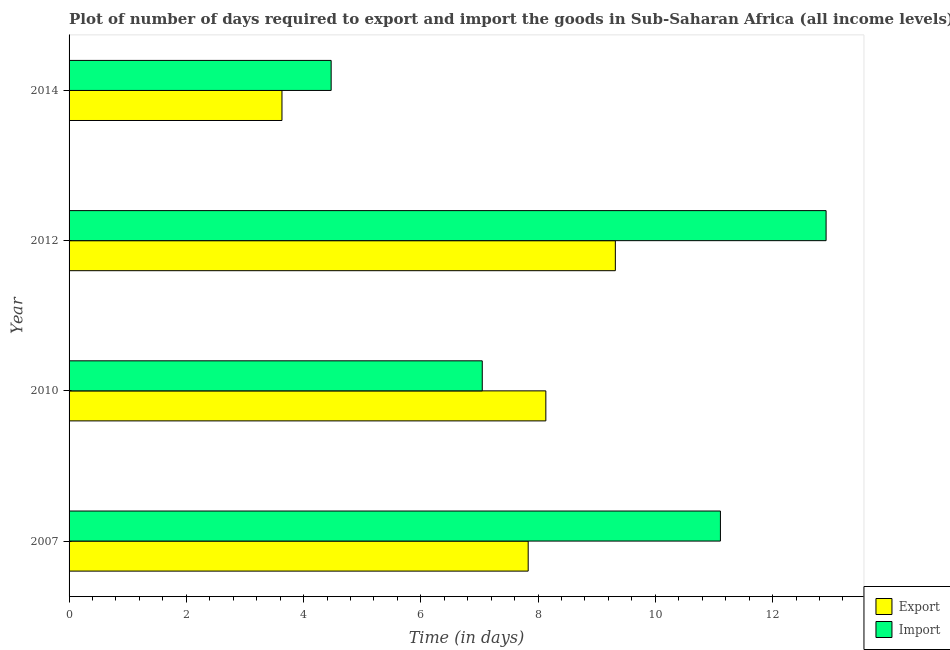How many different coloured bars are there?
Make the answer very short. 2. How many groups of bars are there?
Your response must be concise. 4. Are the number of bars per tick equal to the number of legend labels?
Offer a very short reply. Yes. How many bars are there on the 4th tick from the top?
Keep it short and to the point. 2. In how many cases, is the number of bars for a given year not equal to the number of legend labels?
Offer a terse response. 0. What is the time required to export in 2010?
Your answer should be very brief. 8.13. Across all years, what is the maximum time required to import?
Offer a very short reply. 12.91. Across all years, what is the minimum time required to export?
Your answer should be compact. 3.63. In which year was the time required to export maximum?
Make the answer very short. 2012. What is the total time required to import in the graph?
Ensure brevity in your answer.  35.54. What is the difference between the time required to import in 2007 and that in 2014?
Make the answer very short. 6.64. What is the difference between the time required to import in 2010 and the time required to export in 2012?
Make the answer very short. -2.27. What is the average time required to export per year?
Your answer should be compact. 7.23. In the year 2012, what is the difference between the time required to import and time required to export?
Offer a very short reply. 3.6. What is the ratio of the time required to export in 2012 to that in 2014?
Provide a short and direct response. 2.57. What is the difference between the highest and the second highest time required to import?
Your answer should be very brief. 1.8. What is the difference between the highest and the lowest time required to import?
Give a very brief answer. 8.44. What does the 1st bar from the top in 2010 represents?
Your response must be concise. Import. What does the 2nd bar from the bottom in 2014 represents?
Offer a very short reply. Import. How many years are there in the graph?
Provide a short and direct response. 4. What is the difference between two consecutive major ticks on the X-axis?
Your response must be concise. 2. Does the graph contain any zero values?
Your answer should be compact. No. Does the graph contain grids?
Make the answer very short. No. How many legend labels are there?
Ensure brevity in your answer.  2. What is the title of the graph?
Give a very brief answer. Plot of number of days required to export and import the goods in Sub-Saharan Africa (all income levels). Does "Stunting" appear as one of the legend labels in the graph?
Your answer should be compact. No. What is the label or title of the X-axis?
Give a very brief answer. Time (in days). What is the label or title of the Y-axis?
Your answer should be very brief. Year. What is the Time (in days) in Export in 2007?
Provide a succinct answer. 7.83. What is the Time (in days) in Import in 2007?
Offer a terse response. 11.11. What is the Time (in days) in Export in 2010?
Offer a terse response. 8.13. What is the Time (in days) of Import in 2010?
Provide a succinct answer. 7.05. What is the Time (in days) in Export in 2012?
Offer a very short reply. 9.32. What is the Time (in days) in Import in 2012?
Make the answer very short. 12.91. What is the Time (in days) in Export in 2014?
Your response must be concise. 3.63. What is the Time (in days) in Import in 2014?
Provide a succinct answer. 4.47. Across all years, what is the maximum Time (in days) in Export?
Provide a short and direct response. 9.32. Across all years, what is the maximum Time (in days) in Import?
Offer a very short reply. 12.91. Across all years, what is the minimum Time (in days) in Export?
Ensure brevity in your answer.  3.63. Across all years, what is the minimum Time (in days) in Import?
Make the answer very short. 4.47. What is the total Time (in days) in Export in the graph?
Offer a terse response. 28.91. What is the total Time (in days) of Import in the graph?
Offer a very short reply. 35.54. What is the difference between the Time (in days) in Export in 2007 and that in 2010?
Give a very brief answer. -0.3. What is the difference between the Time (in days) of Import in 2007 and that in 2010?
Keep it short and to the point. 4.06. What is the difference between the Time (in days) of Export in 2007 and that in 2012?
Ensure brevity in your answer.  -1.49. What is the difference between the Time (in days) in Import in 2007 and that in 2012?
Provide a succinct answer. -1.8. What is the difference between the Time (in days) of Import in 2007 and that in 2014?
Your answer should be compact. 6.64. What is the difference between the Time (in days) in Export in 2010 and that in 2012?
Your response must be concise. -1.19. What is the difference between the Time (in days) of Import in 2010 and that in 2012?
Offer a terse response. -5.86. What is the difference between the Time (in days) of Export in 2010 and that in 2014?
Your answer should be very brief. 4.5. What is the difference between the Time (in days) in Import in 2010 and that in 2014?
Keep it short and to the point. 2.58. What is the difference between the Time (in days) in Export in 2012 and that in 2014?
Your response must be concise. 5.69. What is the difference between the Time (in days) in Import in 2012 and that in 2014?
Offer a very short reply. 8.44. What is the difference between the Time (in days) of Export in 2007 and the Time (in days) of Import in 2010?
Provide a short and direct response. 0.78. What is the difference between the Time (in days) of Export in 2007 and the Time (in days) of Import in 2012?
Offer a terse response. -5.08. What is the difference between the Time (in days) in Export in 2007 and the Time (in days) in Import in 2014?
Your answer should be compact. 3.36. What is the difference between the Time (in days) in Export in 2010 and the Time (in days) in Import in 2012?
Give a very brief answer. -4.78. What is the difference between the Time (in days) in Export in 2010 and the Time (in days) in Import in 2014?
Provide a succinct answer. 3.66. What is the difference between the Time (in days) in Export in 2012 and the Time (in days) in Import in 2014?
Ensure brevity in your answer.  4.85. What is the average Time (in days) in Export per year?
Offer a very short reply. 7.23. What is the average Time (in days) in Import per year?
Provide a short and direct response. 8.89. In the year 2007, what is the difference between the Time (in days) of Export and Time (in days) of Import?
Give a very brief answer. -3.28. In the year 2010, what is the difference between the Time (in days) in Export and Time (in days) in Import?
Provide a short and direct response. 1.08. In the year 2012, what is the difference between the Time (in days) in Export and Time (in days) in Import?
Offer a very short reply. -3.59. In the year 2014, what is the difference between the Time (in days) of Export and Time (in days) of Import?
Give a very brief answer. -0.84. What is the ratio of the Time (in days) in Export in 2007 to that in 2010?
Offer a very short reply. 0.96. What is the ratio of the Time (in days) in Import in 2007 to that in 2010?
Your answer should be compact. 1.58. What is the ratio of the Time (in days) of Export in 2007 to that in 2012?
Your answer should be compact. 0.84. What is the ratio of the Time (in days) of Import in 2007 to that in 2012?
Your answer should be very brief. 0.86. What is the ratio of the Time (in days) of Export in 2007 to that in 2014?
Make the answer very short. 2.16. What is the ratio of the Time (in days) of Import in 2007 to that in 2014?
Offer a very short reply. 2.49. What is the ratio of the Time (in days) of Export in 2010 to that in 2012?
Provide a succinct answer. 0.87. What is the ratio of the Time (in days) in Import in 2010 to that in 2012?
Offer a very short reply. 0.55. What is the ratio of the Time (in days) of Export in 2010 to that in 2014?
Offer a terse response. 2.24. What is the ratio of the Time (in days) in Import in 2010 to that in 2014?
Give a very brief answer. 1.58. What is the ratio of the Time (in days) in Export in 2012 to that in 2014?
Your response must be concise. 2.57. What is the ratio of the Time (in days) in Import in 2012 to that in 2014?
Ensure brevity in your answer.  2.89. What is the difference between the highest and the second highest Time (in days) of Export?
Give a very brief answer. 1.19. What is the difference between the highest and the second highest Time (in days) of Import?
Your answer should be very brief. 1.8. What is the difference between the highest and the lowest Time (in days) of Export?
Your answer should be very brief. 5.69. What is the difference between the highest and the lowest Time (in days) in Import?
Your answer should be compact. 8.44. 